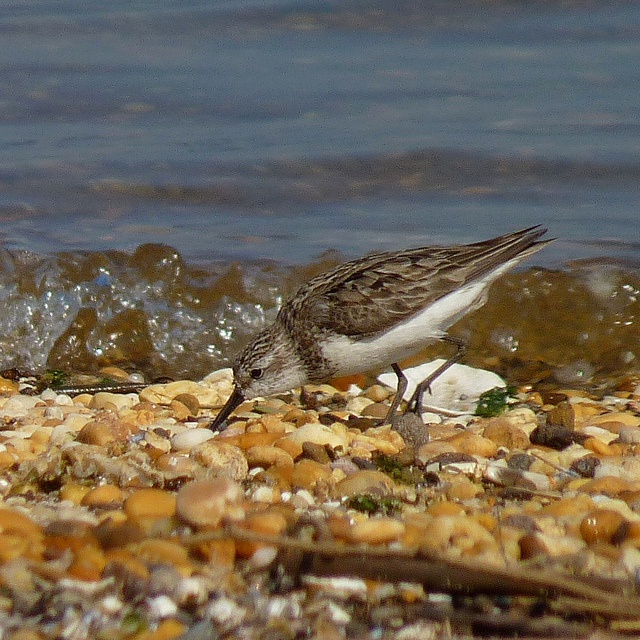Describe the objects in this image and their specific colors. I can see a bird in gray, black, and maroon tones in this image. 